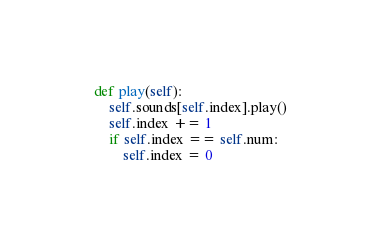Convert code to text. <code><loc_0><loc_0><loc_500><loc_500><_Python_>    def play(self):
        self.sounds[self.index].play()
        self.index += 1
        if self.index == self.num:
            self.index = 0</code> 